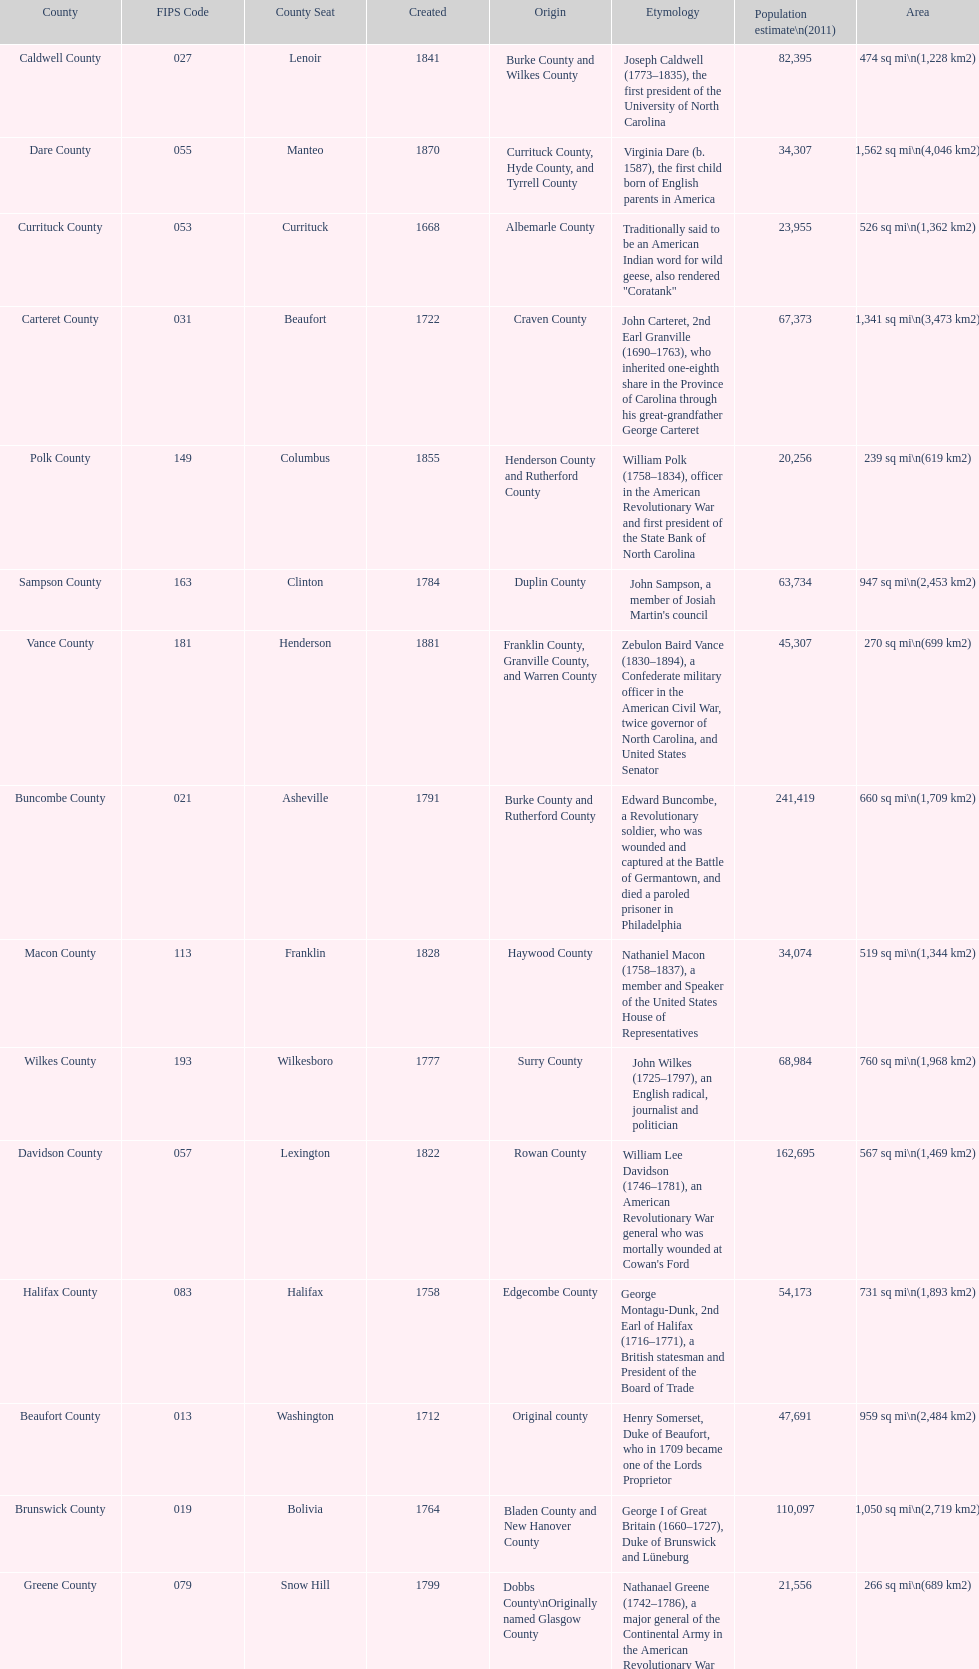What is the only county whose name comes from a battle? Alamance County. 